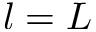Convert formula to latex. <formula><loc_0><loc_0><loc_500><loc_500>l = L</formula> 